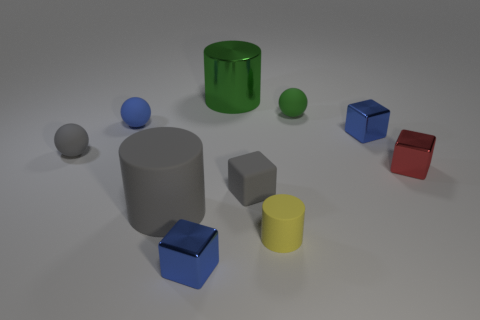Subtract all cubes. How many objects are left? 6 Subtract all large shiny cylinders. Subtract all green things. How many objects are left? 7 Add 8 small red things. How many small red things are left? 9 Add 5 small red metallic objects. How many small red metallic objects exist? 6 Subtract 1 yellow cylinders. How many objects are left? 9 